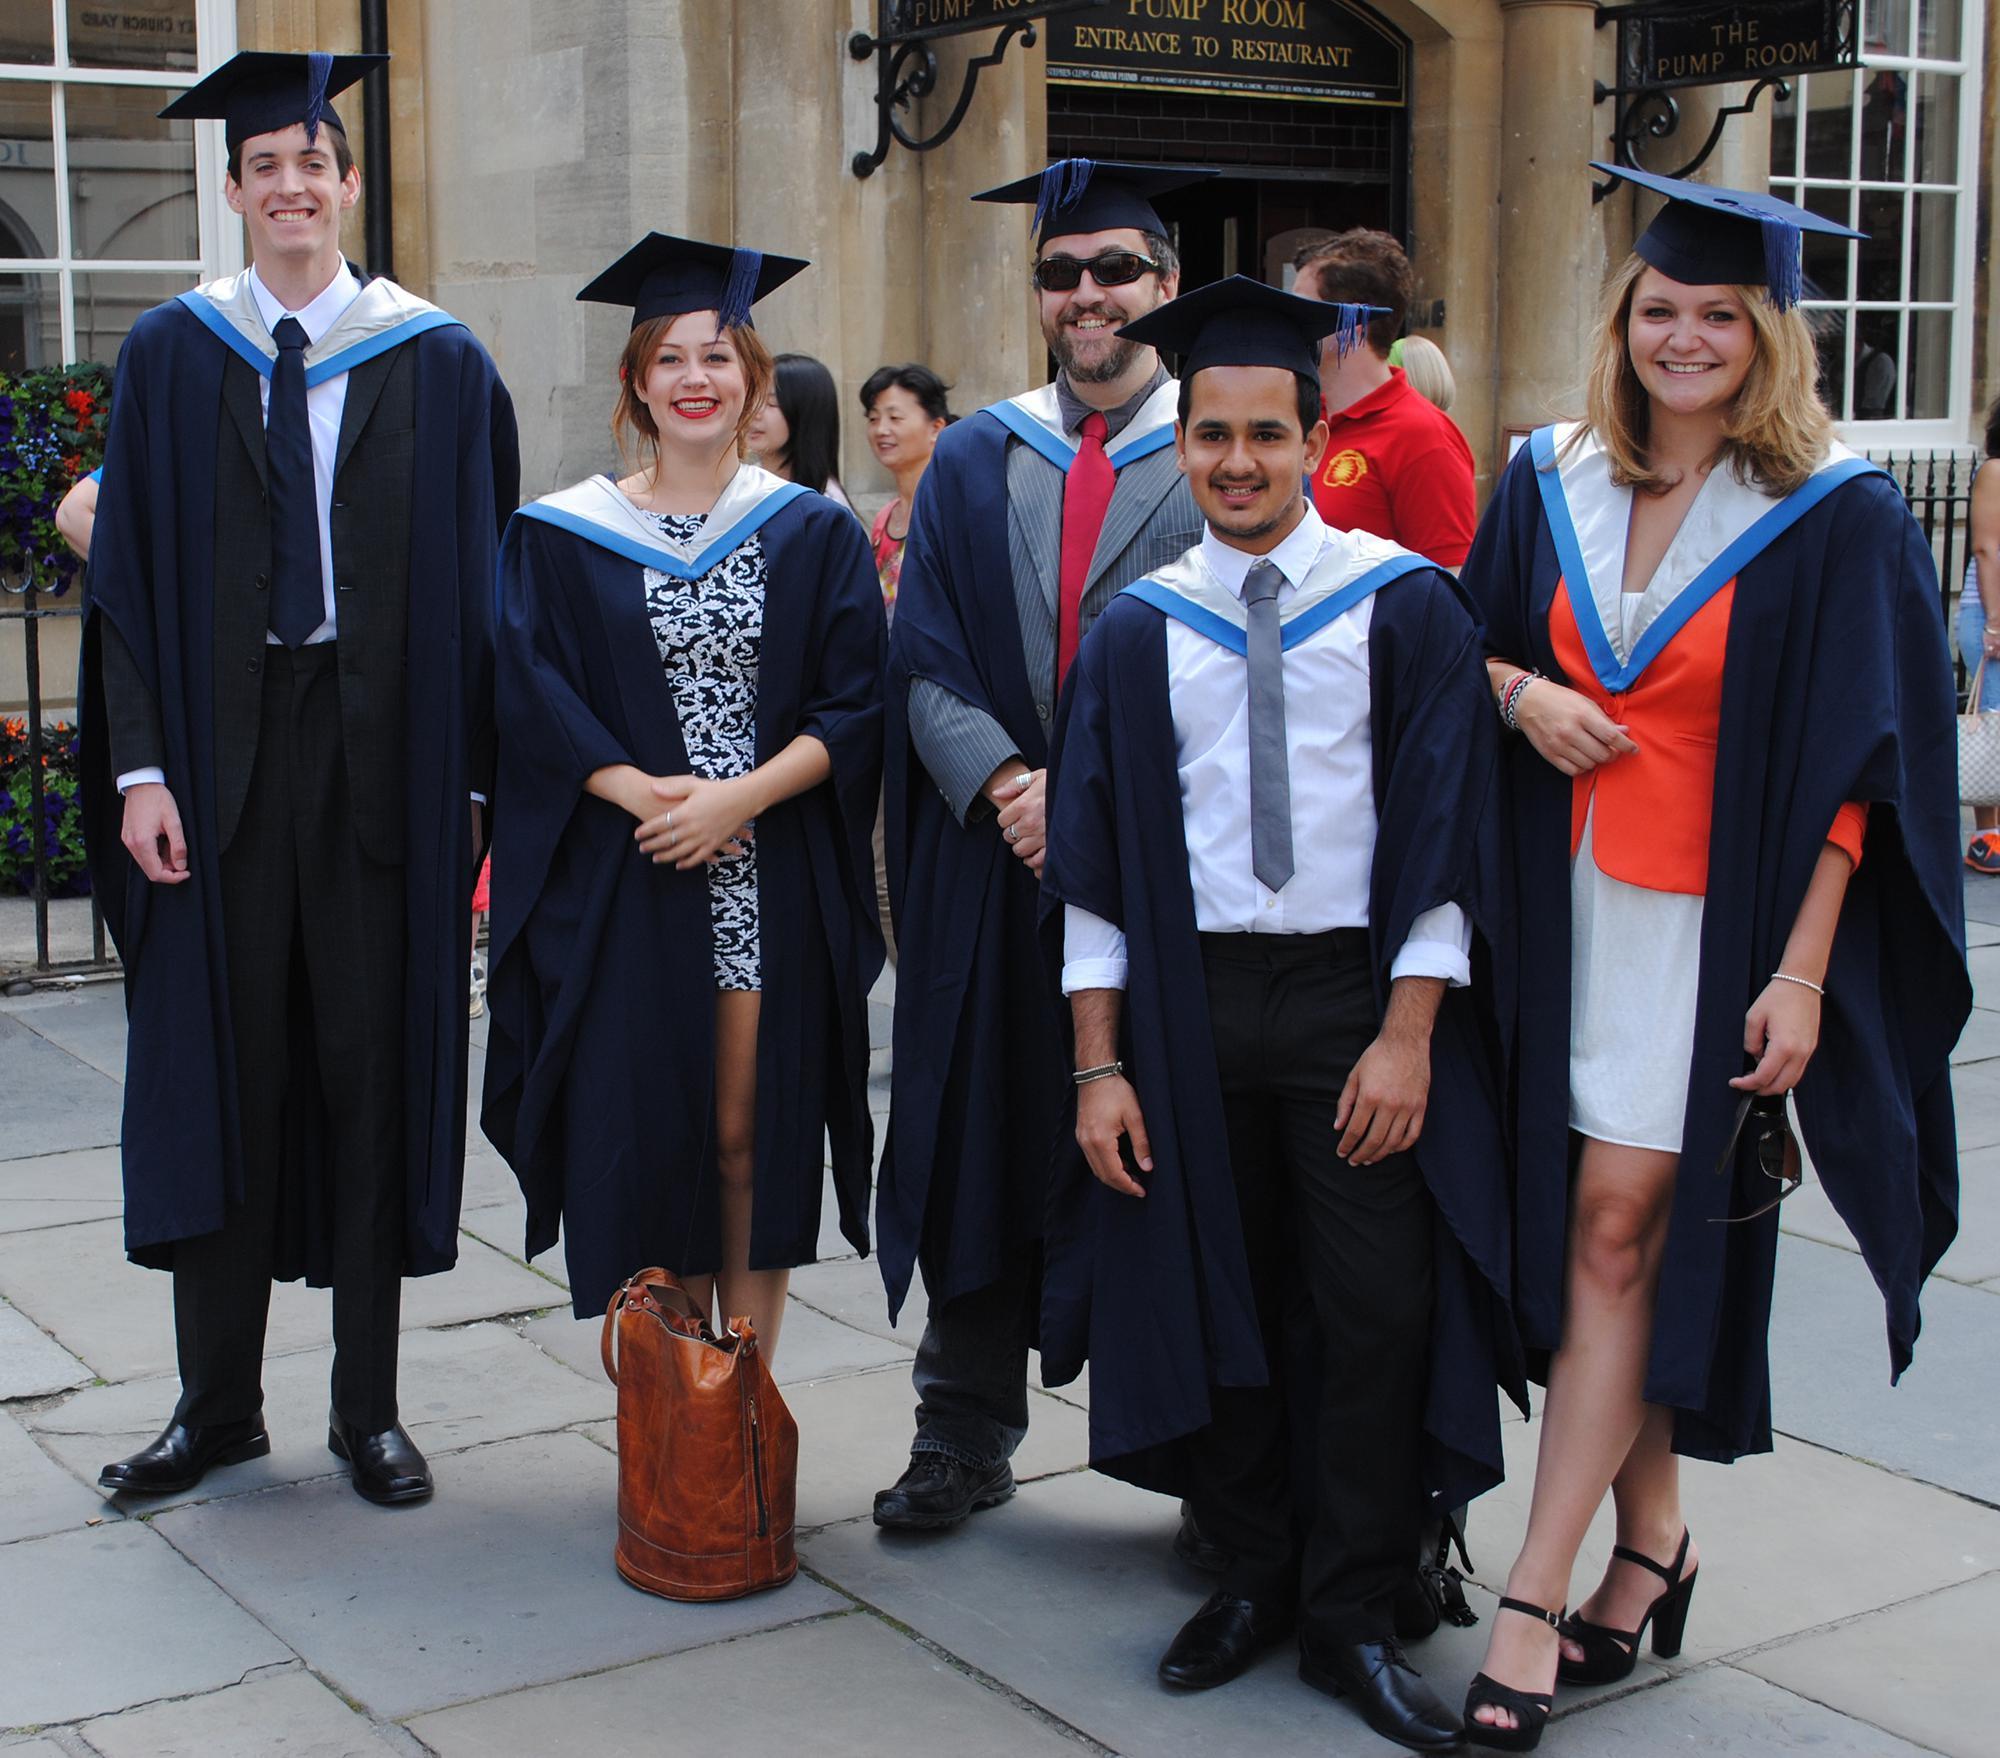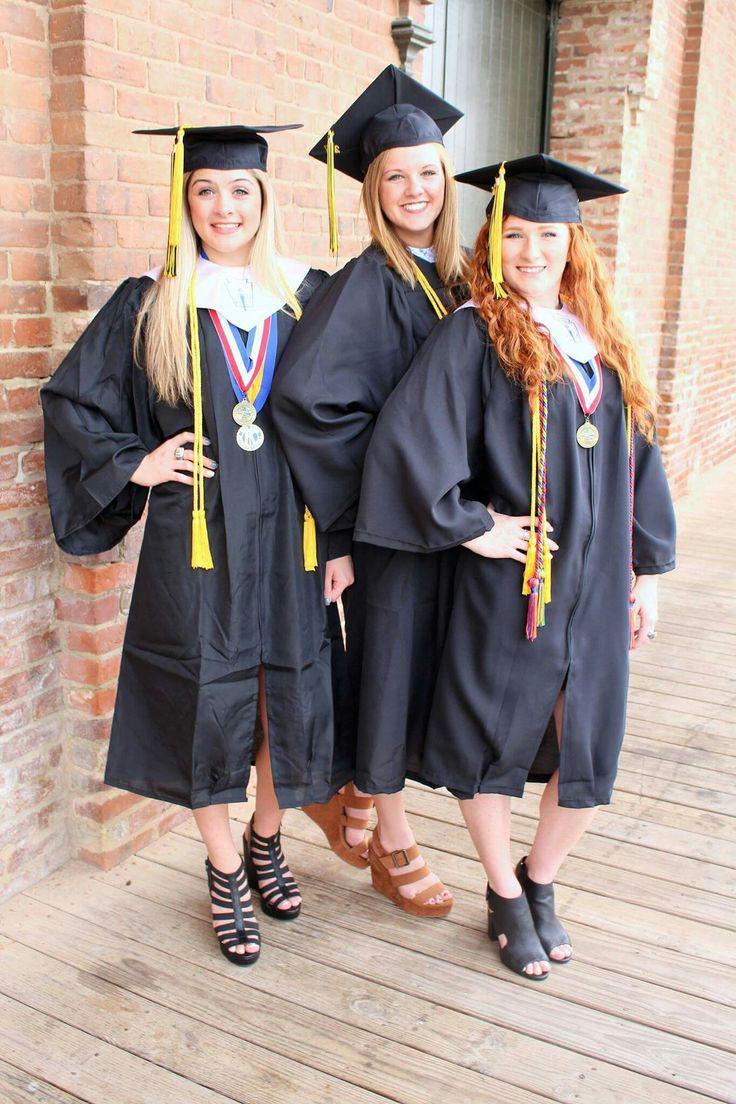The first image is the image on the left, the second image is the image on the right. Evaluate the accuracy of this statement regarding the images: "In one image at least two male graduates are wearing white bow ties and at least one female graduate is wearing an untied black string tie and black hosiery.". Is it true? Answer yes or no. No. The first image is the image on the left, the second image is the image on the right. For the images displayed, is the sentence "The left image contains no more than four graduation students." factually correct? Answer yes or no. No. 